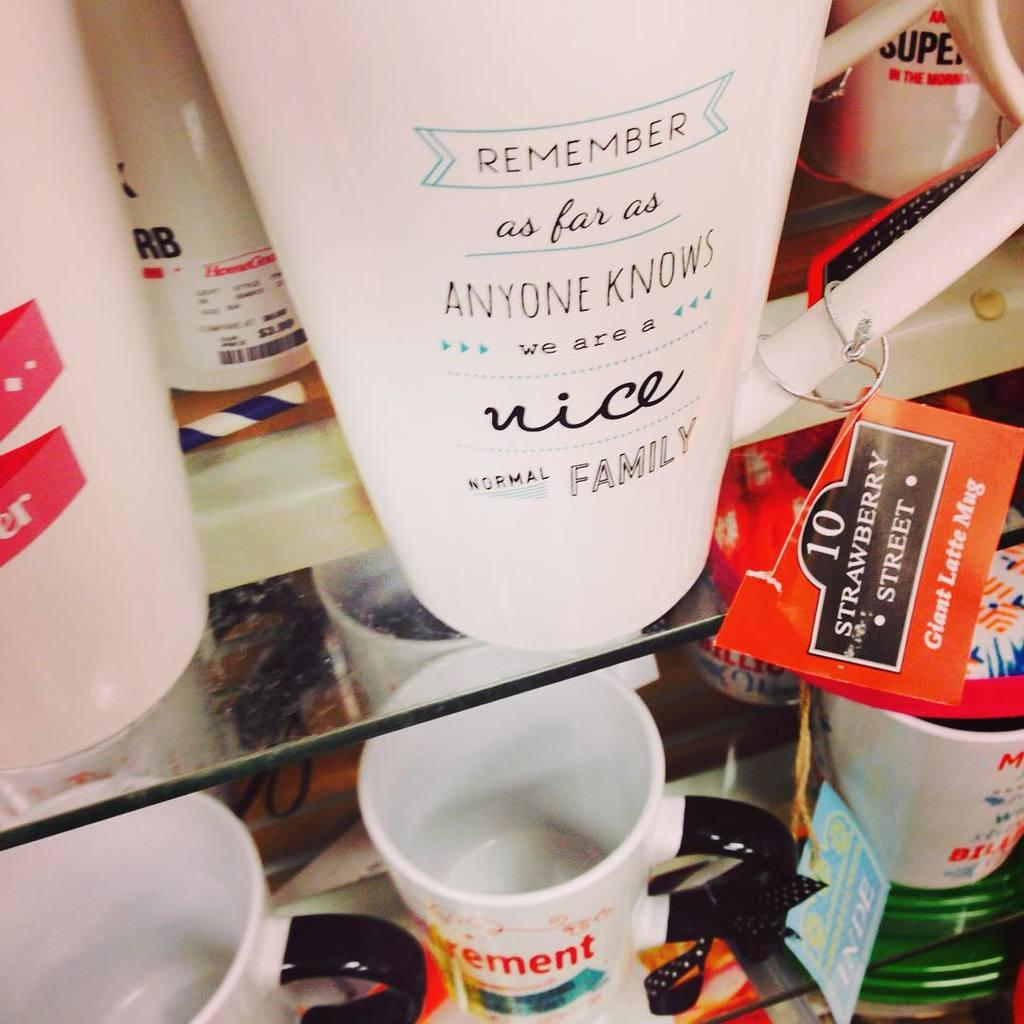Provide a one-sentence caption for the provided image. White cups for sale including one that says "Remember". 